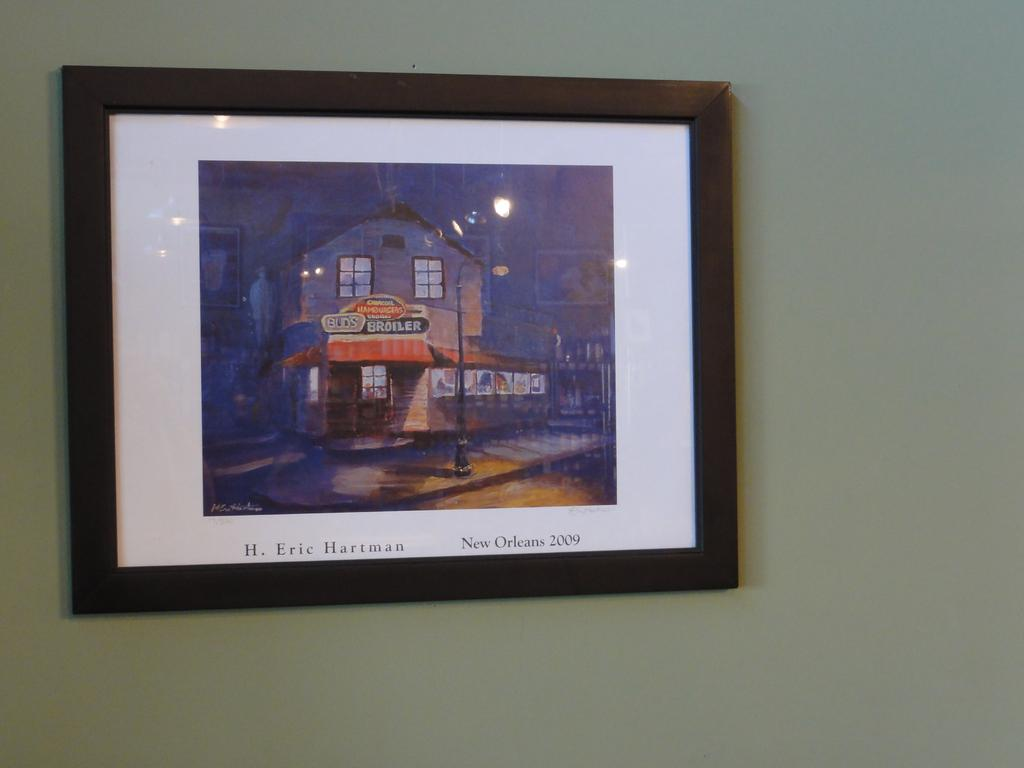Provide a one-sentence caption for the provided image. A picture from New Orleans by H. Eric Hartman. 